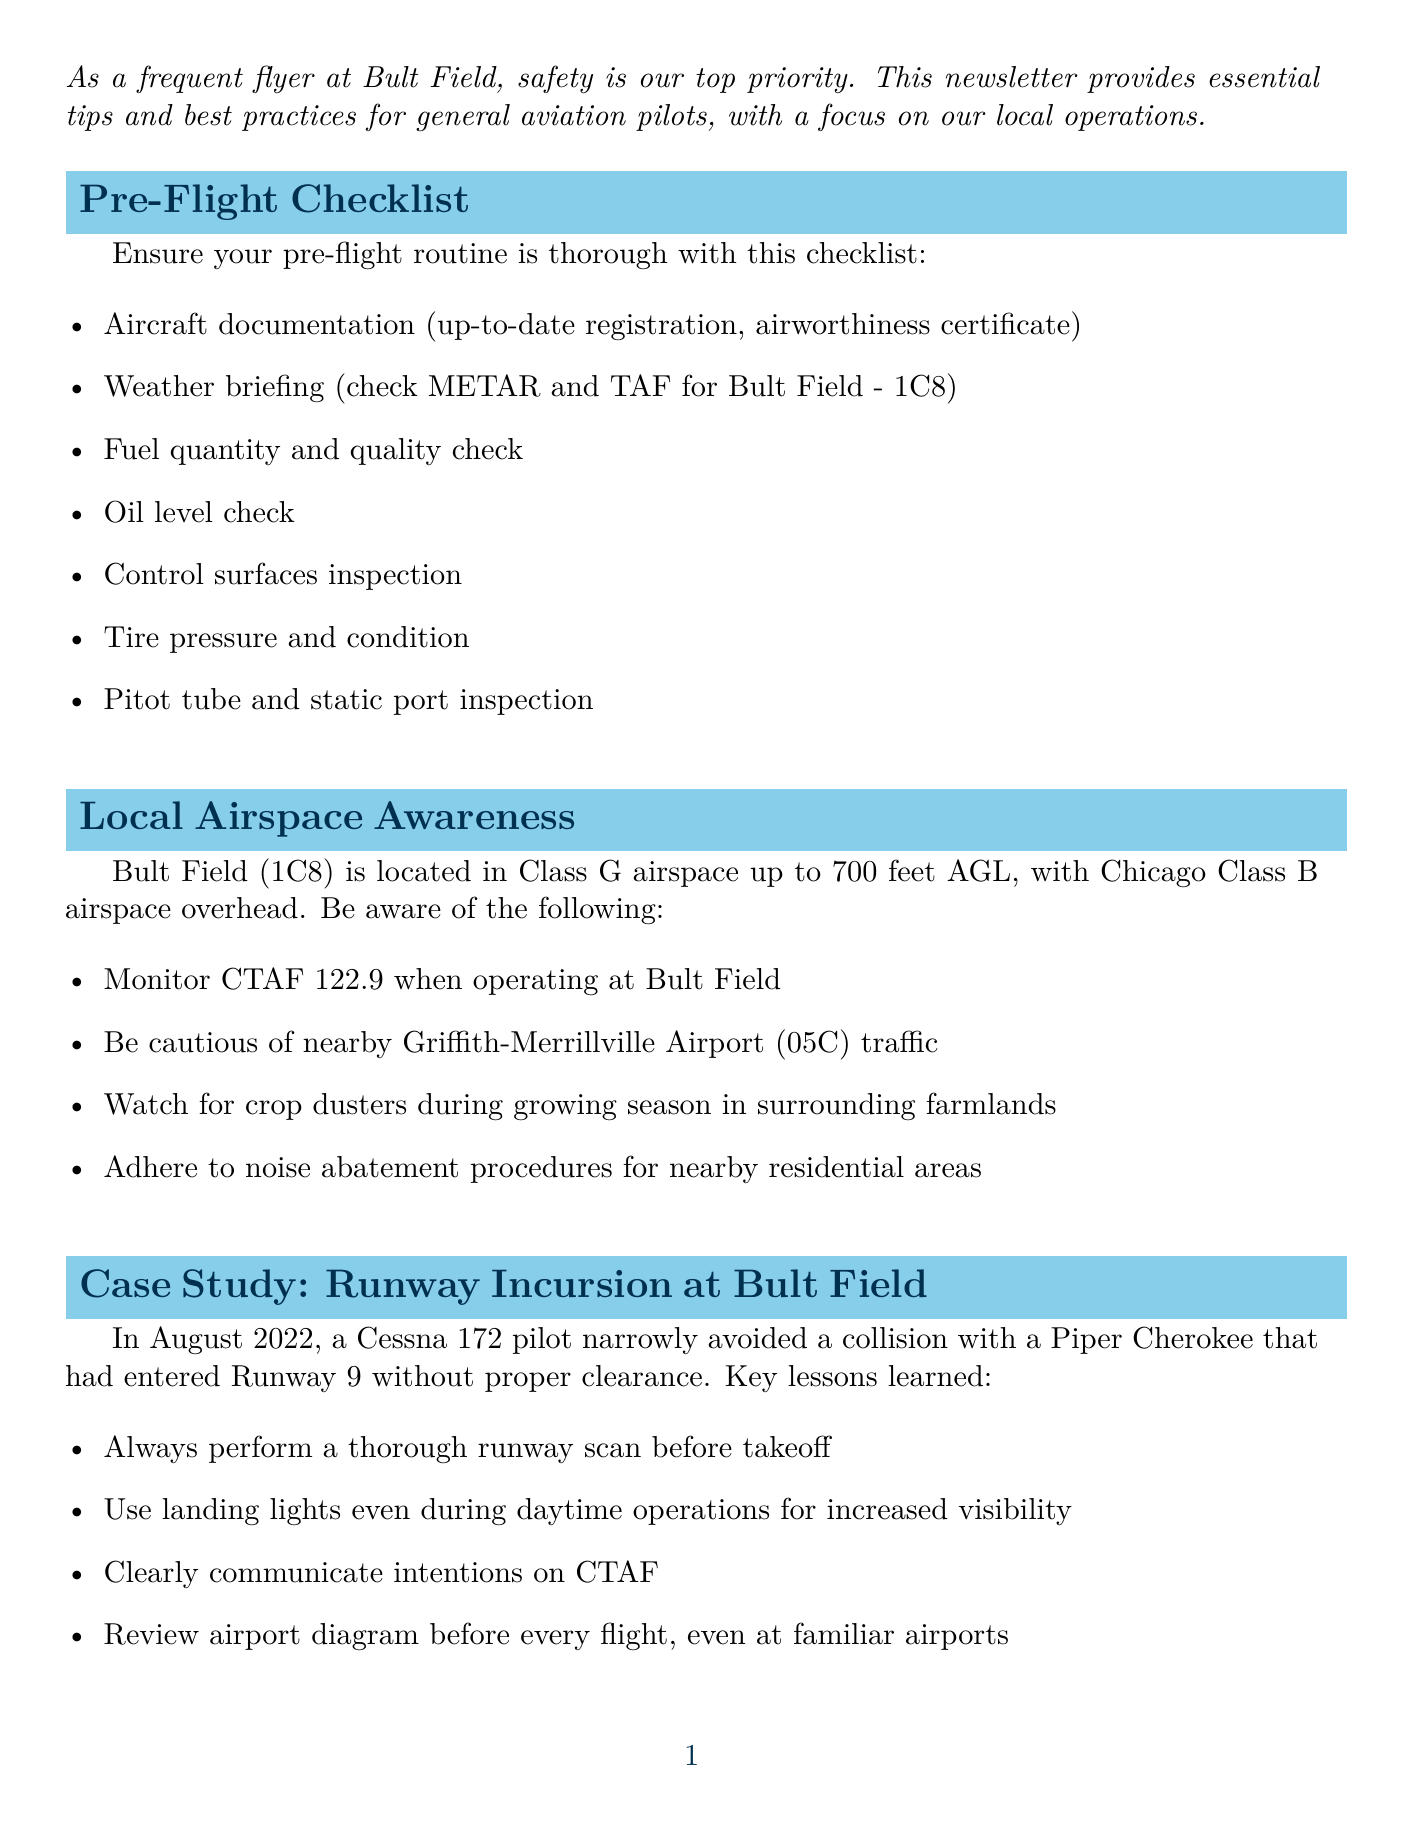what is the newsletter title? The title of the newsletter is stated at the beginning of the document.
Answer: Bult Field Safety Bulletin: Empowering GA Pilots what is the primary focus of the newsletter? The introduction explains the main concern addressed in the newsletter.
Answer: Safety tips and best practices for general aviation pilots how many items are listed in the pre-flight checklist? The Pre-Flight Checklist section contains a bulleted list of items to check before flight.
Answer: seven what is the CTAF frequency to monitor when operating at Bult Field? The Local Airspace Awareness section provides specific information about the CTAF frequency.
Answer: 122.9 what incident case study is mentioned in the newsletter? The Case Study section describes a specific incident that occurred at Bult Field.
Answer: Runway Incursion at Bult Field what is one key lesson learned from the case study? The Case Study section highlights important lessons drawn from the incident.
Answer: Always perform a thorough runway scan before takeoff which organization should be contacted for reporting emergencies? The Local Resources section provides contact information for emergency management.
Answer: Will County Emergency Management what type of weather condition should pilots be prepared for near Lake Michigan? The Weather Considerations section discusses the weather risks associated with the location.
Answer: Sudden fog formation how many emergency procedures are detailed in the newsletter? The Emergency Procedures Refresher section outlines different types of emergencies and their responses.
Answer: two what is the contact number for the Bult Field FBO? The Local Resources section provides contact information for the FBO at Bult Field.
Answer: +1 (708) 534-8282 